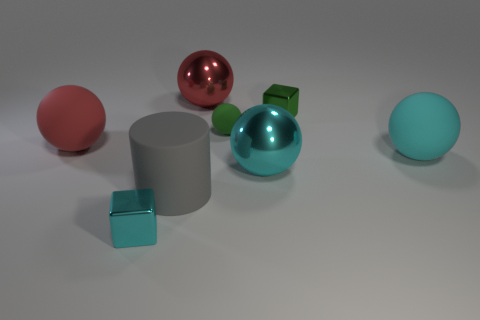There is a green rubber object that is behind the large red rubber sphere; how many big cyan matte objects are right of it?
Keep it short and to the point. 1. Do the block that is in front of the green matte sphere and the big gray rubber object have the same size?
Give a very brief answer. No. How many large cyan metal objects are the same shape as the big gray thing?
Offer a terse response. 0. The large cyan metal thing is what shape?
Your response must be concise. Sphere. Are there the same number of tiny green objects that are in front of the small green matte ball and metal spheres?
Ensure brevity in your answer.  No. Are there any other things that have the same material as the small green cube?
Your answer should be very brief. Yes. Does the cube that is behind the red matte ball have the same material as the tiny green sphere?
Make the answer very short. No. Is the number of tiny green rubber objects that are in front of the cyan matte object less than the number of large yellow balls?
Your response must be concise. No. What number of metal things are cyan cubes or big spheres?
Provide a short and direct response. 3. Is the small ball the same color as the matte cylinder?
Offer a very short reply. No. 